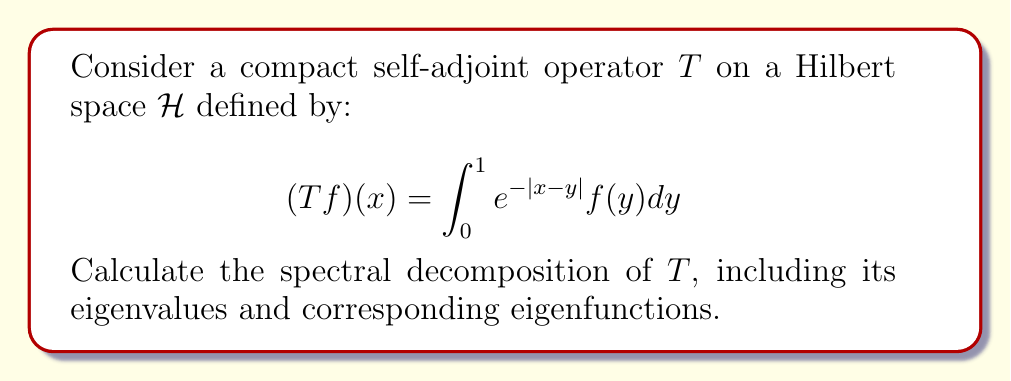Give your solution to this math problem. To find the spectral decomposition of $T$, we need to follow these steps:

1) First, we need to find the eigenvalues and eigenfunctions of $T$. For a compact self-adjoint operator, all eigenvalues are real.

2) The eigenvalue equation is:

   $$(Tf)(x) = \lambda f(x)$$

3) Substituting the definition of $T$:

   $$\int_0^1 e^{-|x-y|}f(y)dy = \lambda f(x)$$

4) Differentiating both sides twice with respect to $x$:

   $$\frac{d^2}{dx^2}\int_0^1 e^{-|x-y|}f(y)dy = \lambda \frac{d^2f}{dx^2}(x)$$

5) The left-hand side simplifies to:

   $$f(x) - \lambda \frac{d^2f}{dx^2}(x) = 0$$

6) This is a second-order differential equation. Its general solution is:

   $$f(x) = A\cos(\frac{x}{\sqrt{\lambda}}) + B\sin(\frac{x}{\sqrt{\lambda}})$$

7) Applying the boundary conditions $f(0) = f(1) = 0$, we get:

   $$A = 0 \text{ and } \sin(\frac{1}{\sqrt{\lambda}}) = 0$$

8) The solutions to this equation are:

   $$\lambda_n = \frac{1}{n^2\pi^2}, \quad n = 1, 2, 3, ...$$

9) The corresponding normalized eigenfunctions are:

   $$f_n(x) = \sqrt{2}\sin(n\pi x), \quad n = 1, 2, 3, ...$$

10) The spectral decomposition of $T$ is given by:

    $$T = \sum_{n=1}^{\infty} \lambda_n (\cdot, f_n)f_n$$

    where $(\cdot, f_n)$ denotes the inner product with $f_n$.
Answer: $T = \sum_{n=1}^{\infty} \frac{1}{n^2\pi^2} (\cdot, \sqrt{2}\sin(n\pi x))\sqrt{2}\sin(n\pi x)$ 